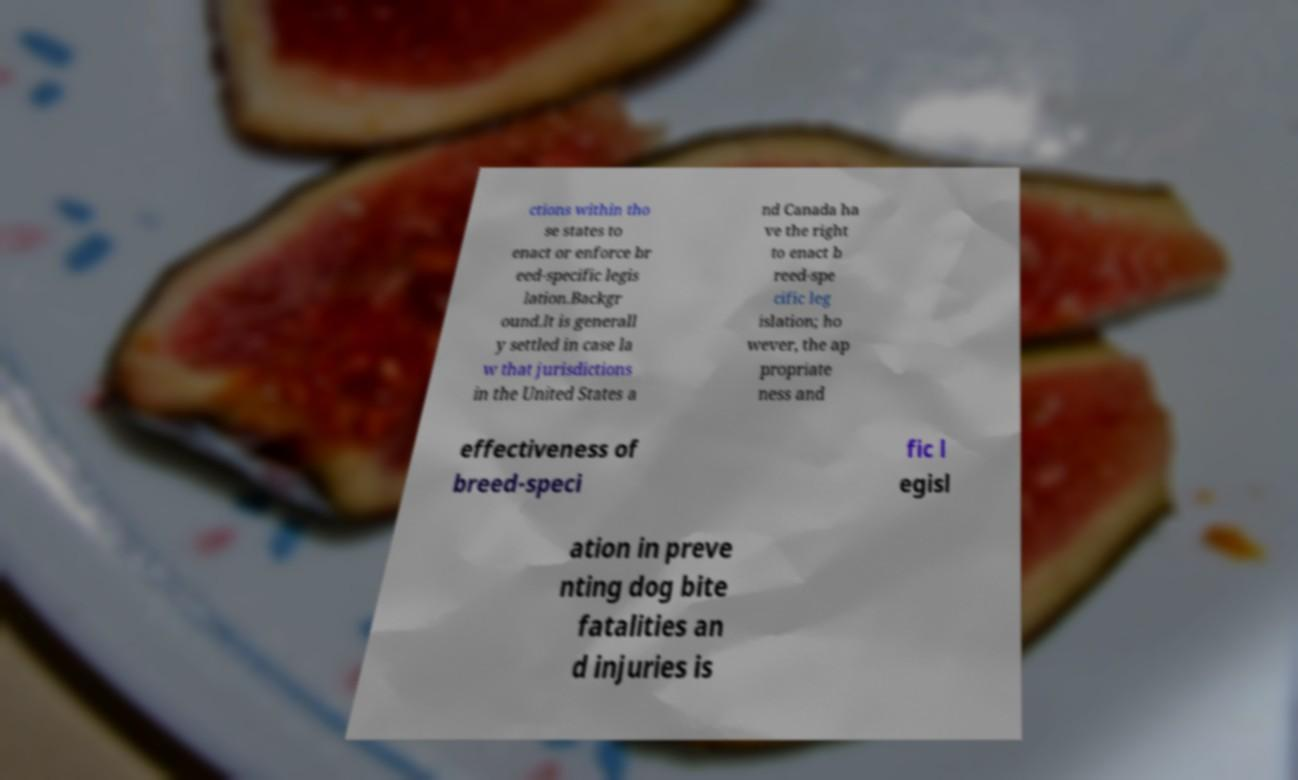What messages or text are displayed in this image? I need them in a readable, typed format. ctions within tho se states to enact or enforce br eed-specific legis lation.Backgr ound.It is generall y settled in case la w that jurisdictions in the United States a nd Canada ha ve the right to enact b reed-spe cific leg islation; ho wever, the ap propriate ness and effectiveness of breed-speci fic l egisl ation in preve nting dog bite fatalities an d injuries is 